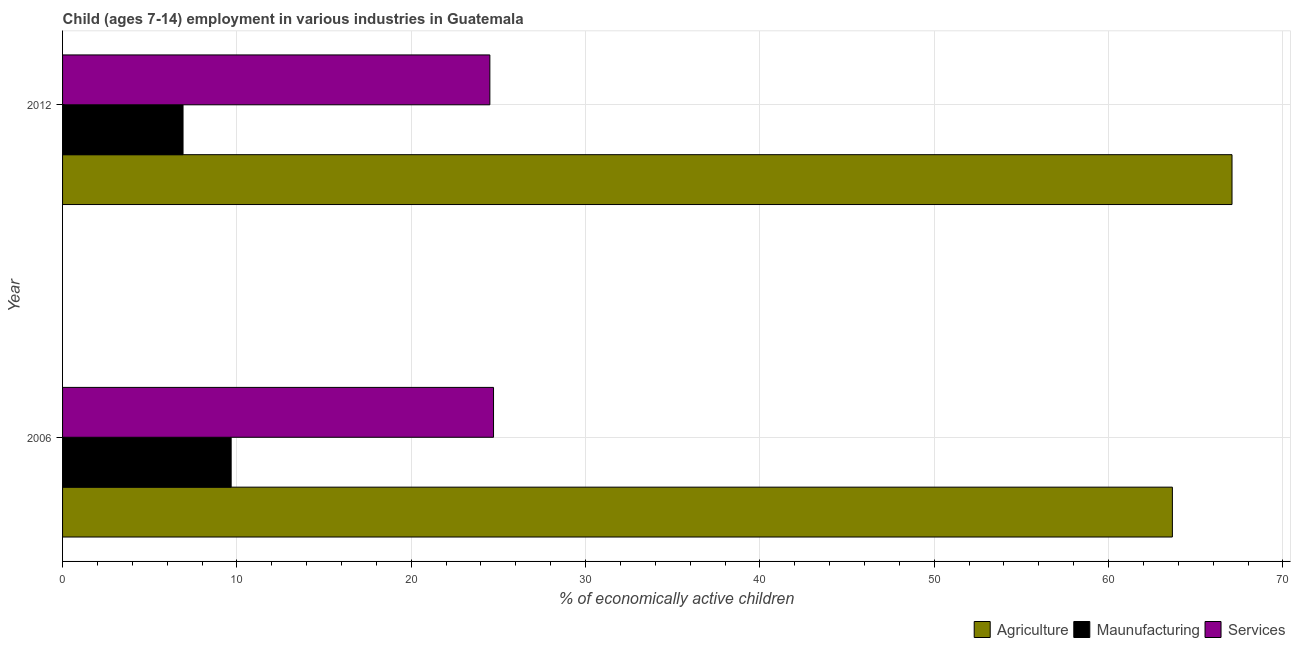How many groups of bars are there?
Your response must be concise. 2. Are the number of bars per tick equal to the number of legend labels?
Provide a succinct answer. Yes. How many bars are there on the 1st tick from the bottom?
Provide a short and direct response. 3. What is the label of the 2nd group of bars from the top?
Your response must be concise. 2006. In how many cases, is the number of bars for a given year not equal to the number of legend labels?
Offer a terse response. 0. What is the percentage of economically active children in manufacturing in 2006?
Give a very brief answer. 9.67. Across all years, what is the maximum percentage of economically active children in services?
Keep it short and to the point. 24.72. Across all years, what is the minimum percentage of economically active children in services?
Provide a succinct answer. 24.51. What is the total percentage of economically active children in manufacturing in the graph?
Keep it short and to the point. 16.58. What is the difference between the percentage of economically active children in manufacturing in 2006 and that in 2012?
Give a very brief answer. 2.76. What is the difference between the percentage of economically active children in agriculture in 2006 and the percentage of economically active children in services in 2012?
Provide a succinct answer. 39.15. What is the average percentage of economically active children in manufacturing per year?
Provide a short and direct response. 8.29. In the year 2012, what is the difference between the percentage of economically active children in services and percentage of economically active children in manufacturing?
Your answer should be very brief. 17.6. In how many years, is the percentage of economically active children in manufacturing greater than 54 %?
Your response must be concise. 0. Is the percentage of economically active children in services in 2006 less than that in 2012?
Offer a very short reply. No. Is the difference between the percentage of economically active children in services in 2006 and 2012 greater than the difference between the percentage of economically active children in agriculture in 2006 and 2012?
Offer a terse response. Yes. What does the 1st bar from the top in 2012 represents?
Offer a terse response. Services. What does the 2nd bar from the bottom in 2012 represents?
Your answer should be compact. Maunufacturing. Is it the case that in every year, the sum of the percentage of economically active children in agriculture and percentage of economically active children in manufacturing is greater than the percentage of economically active children in services?
Keep it short and to the point. Yes. Are all the bars in the graph horizontal?
Provide a short and direct response. Yes. What is the difference between two consecutive major ticks on the X-axis?
Your answer should be compact. 10. Are the values on the major ticks of X-axis written in scientific E-notation?
Ensure brevity in your answer.  No. Does the graph contain any zero values?
Give a very brief answer. No. Does the graph contain grids?
Make the answer very short. Yes. How are the legend labels stacked?
Provide a short and direct response. Horizontal. What is the title of the graph?
Give a very brief answer. Child (ages 7-14) employment in various industries in Guatemala. What is the label or title of the X-axis?
Provide a short and direct response. % of economically active children. What is the label or title of the Y-axis?
Give a very brief answer. Year. What is the % of economically active children in Agriculture in 2006?
Your answer should be compact. 63.66. What is the % of economically active children in Maunufacturing in 2006?
Offer a terse response. 9.67. What is the % of economically active children of Services in 2006?
Your response must be concise. 24.72. What is the % of economically active children of Agriculture in 2012?
Offer a terse response. 67.08. What is the % of economically active children of Maunufacturing in 2012?
Your answer should be very brief. 6.91. What is the % of economically active children of Services in 2012?
Offer a terse response. 24.51. Across all years, what is the maximum % of economically active children in Agriculture?
Give a very brief answer. 67.08. Across all years, what is the maximum % of economically active children in Maunufacturing?
Ensure brevity in your answer.  9.67. Across all years, what is the maximum % of economically active children of Services?
Your answer should be very brief. 24.72. Across all years, what is the minimum % of economically active children in Agriculture?
Provide a short and direct response. 63.66. Across all years, what is the minimum % of economically active children of Maunufacturing?
Offer a very short reply. 6.91. Across all years, what is the minimum % of economically active children in Services?
Provide a succinct answer. 24.51. What is the total % of economically active children in Agriculture in the graph?
Offer a very short reply. 130.74. What is the total % of economically active children in Maunufacturing in the graph?
Provide a succinct answer. 16.58. What is the total % of economically active children in Services in the graph?
Give a very brief answer. 49.23. What is the difference between the % of economically active children of Agriculture in 2006 and that in 2012?
Offer a terse response. -3.42. What is the difference between the % of economically active children in Maunufacturing in 2006 and that in 2012?
Your answer should be compact. 2.76. What is the difference between the % of economically active children in Services in 2006 and that in 2012?
Make the answer very short. 0.21. What is the difference between the % of economically active children of Agriculture in 2006 and the % of economically active children of Maunufacturing in 2012?
Ensure brevity in your answer.  56.75. What is the difference between the % of economically active children in Agriculture in 2006 and the % of economically active children in Services in 2012?
Make the answer very short. 39.15. What is the difference between the % of economically active children in Maunufacturing in 2006 and the % of economically active children in Services in 2012?
Keep it short and to the point. -14.84. What is the average % of economically active children in Agriculture per year?
Your response must be concise. 65.37. What is the average % of economically active children in Maunufacturing per year?
Give a very brief answer. 8.29. What is the average % of economically active children of Services per year?
Your answer should be very brief. 24.61. In the year 2006, what is the difference between the % of economically active children of Agriculture and % of economically active children of Maunufacturing?
Give a very brief answer. 53.99. In the year 2006, what is the difference between the % of economically active children in Agriculture and % of economically active children in Services?
Provide a succinct answer. 38.94. In the year 2006, what is the difference between the % of economically active children of Maunufacturing and % of economically active children of Services?
Ensure brevity in your answer.  -15.05. In the year 2012, what is the difference between the % of economically active children of Agriculture and % of economically active children of Maunufacturing?
Offer a terse response. 60.17. In the year 2012, what is the difference between the % of economically active children in Agriculture and % of economically active children in Services?
Provide a succinct answer. 42.57. In the year 2012, what is the difference between the % of economically active children of Maunufacturing and % of economically active children of Services?
Keep it short and to the point. -17.6. What is the ratio of the % of economically active children in Agriculture in 2006 to that in 2012?
Keep it short and to the point. 0.95. What is the ratio of the % of economically active children in Maunufacturing in 2006 to that in 2012?
Your answer should be very brief. 1.4. What is the ratio of the % of economically active children of Services in 2006 to that in 2012?
Your response must be concise. 1.01. What is the difference between the highest and the second highest % of economically active children of Agriculture?
Ensure brevity in your answer.  3.42. What is the difference between the highest and the second highest % of economically active children in Maunufacturing?
Make the answer very short. 2.76. What is the difference between the highest and the second highest % of economically active children of Services?
Offer a terse response. 0.21. What is the difference between the highest and the lowest % of economically active children in Agriculture?
Provide a succinct answer. 3.42. What is the difference between the highest and the lowest % of economically active children in Maunufacturing?
Make the answer very short. 2.76. What is the difference between the highest and the lowest % of economically active children of Services?
Make the answer very short. 0.21. 